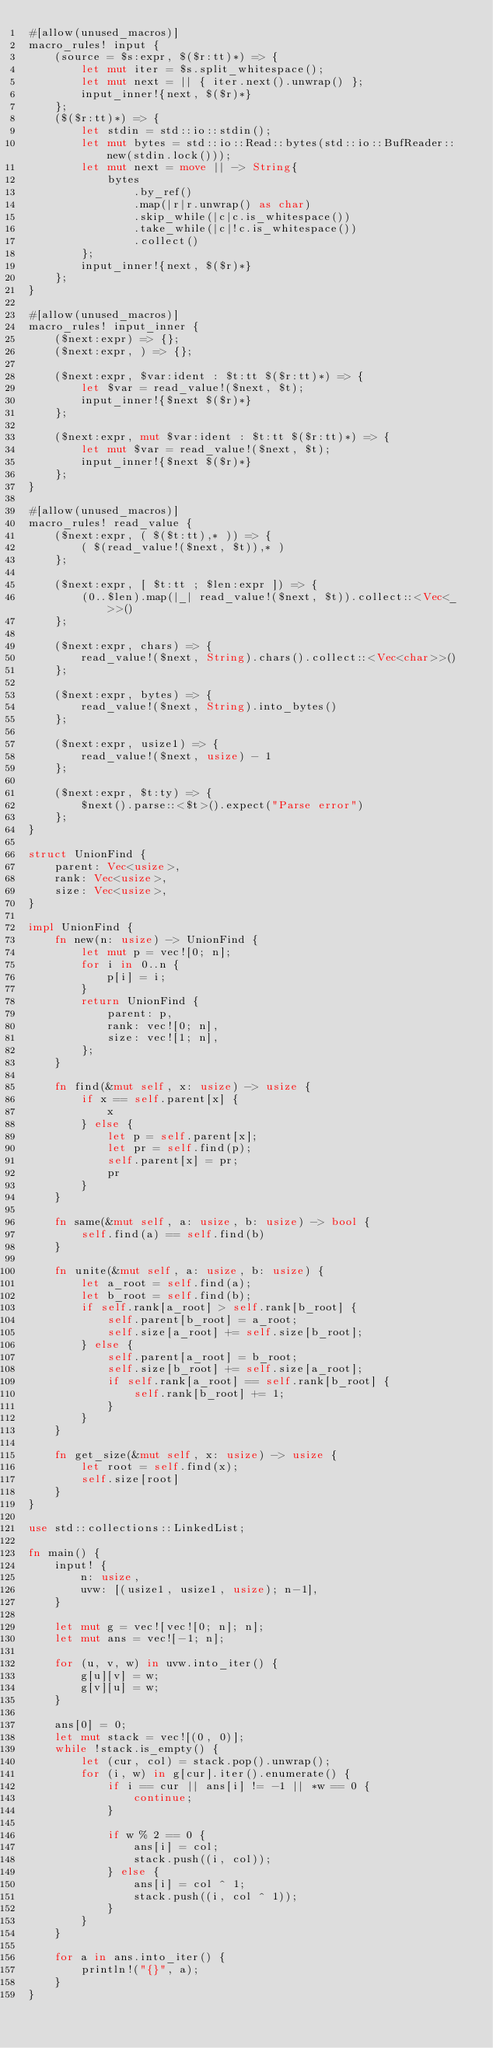Convert code to text. <code><loc_0><loc_0><loc_500><loc_500><_Rust_>#[allow(unused_macros)]
macro_rules! input {
    (source = $s:expr, $($r:tt)*) => {
        let mut iter = $s.split_whitespace();
        let mut next = || { iter.next().unwrap() };
        input_inner!{next, $($r)*}
    };
    ($($r:tt)*) => {
        let stdin = std::io::stdin();
        let mut bytes = std::io::Read::bytes(std::io::BufReader::new(stdin.lock()));
        let mut next = move || -> String{
            bytes
                .by_ref()
                .map(|r|r.unwrap() as char)
                .skip_while(|c|c.is_whitespace())
                .take_while(|c|!c.is_whitespace())
                .collect()
        };
        input_inner!{next, $($r)*}
    };
}

#[allow(unused_macros)]
macro_rules! input_inner {
    ($next:expr) => {};
    ($next:expr, ) => {};

    ($next:expr, $var:ident : $t:tt $($r:tt)*) => {
        let $var = read_value!($next, $t);
        input_inner!{$next $($r)*}
    };

    ($next:expr, mut $var:ident : $t:tt $($r:tt)*) => {
        let mut $var = read_value!($next, $t);
        input_inner!{$next $($r)*}
    };
}

#[allow(unused_macros)]
macro_rules! read_value {
    ($next:expr, ( $($t:tt),* )) => {
        ( $(read_value!($next, $t)),* )
    };

    ($next:expr, [ $t:tt ; $len:expr ]) => {
        (0..$len).map(|_| read_value!($next, $t)).collect::<Vec<_>>()
    };

    ($next:expr, chars) => {
        read_value!($next, String).chars().collect::<Vec<char>>()
    };

    ($next:expr, bytes) => {
        read_value!($next, String).into_bytes()
    };

    ($next:expr, usize1) => {
        read_value!($next, usize) - 1
    };

    ($next:expr, $t:ty) => {
        $next().parse::<$t>().expect("Parse error")
    };
}

struct UnionFind {
    parent: Vec<usize>,
    rank: Vec<usize>,
    size: Vec<usize>,
}

impl UnionFind {
    fn new(n: usize) -> UnionFind {
        let mut p = vec![0; n];
        for i in 0..n {
            p[i] = i;
        }
        return UnionFind {
            parent: p,
            rank: vec![0; n],
            size: vec![1; n],
        };
    }

    fn find(&mut self, x: usize) -> usize {
        if x == self.parent[x] {
            x
        } else {
            let p = self.parent[x];
            let pr = self.find(p);
            self.parent[x] = pr;
            pr
        }
    }

    fn same(&mut self, a: usize, b: usize) -> bool {
        self.find(a) == self.find(b)
    }

    fn unite(&mut self, a: usize, b: usize) {
        let a_root = self.find(a);
        let b_root = self.find(b);
        if self.rank[a_root] > self.rank[b_root] {
            self.parent[b_root] = a_root;
            self.size[a_root] += self.size[b_root];
        } else {
            self.parent[a_root] = b_root;
            self.size[b_root] += self.size[a_root];
            if self.rank[a_root] == self.rank[b_root] {
                self.rank[b_root] += 1;
            }
        }
    }

    fn get_size(&mut self, x: usize) -> usize {
        let root = self.find(x);
        self.size[root]
    }
}

use std::collections::LinkedList;

fn main() {
    input! {
        n: usize,
        uvw: [(usize1, usize1, usize); n-1],
    }

    let mut g = vec![vec![0; n]; n];
    let mut ans = vec![-1; n];

    for (u, v, w) in uvw.into_iter() {
        g[u][v] = w;
        g[v][u] = w;
    }

    ans[0] = 0;
    let mut stack = vec![(0, 0)];
    while !stack.is_empty() {
        let (cur, col) = stack.pop().unwrap();
        for (i, w) in g[cur].iter().enumerate() {
            if i == cur || ans[i] != -1 || *w == 0 {
                continue;
            }

            if w % 2 == 0 {
                ans[i] = col;
                stack.push((i, col));
            } else {
                ans[i] = col ^ 1;
                stack.push((i, col ^ 1));
            }
        }
    }

    for a in ans.into_iter() {
        println!("{}", a);
    }
}
</code> 